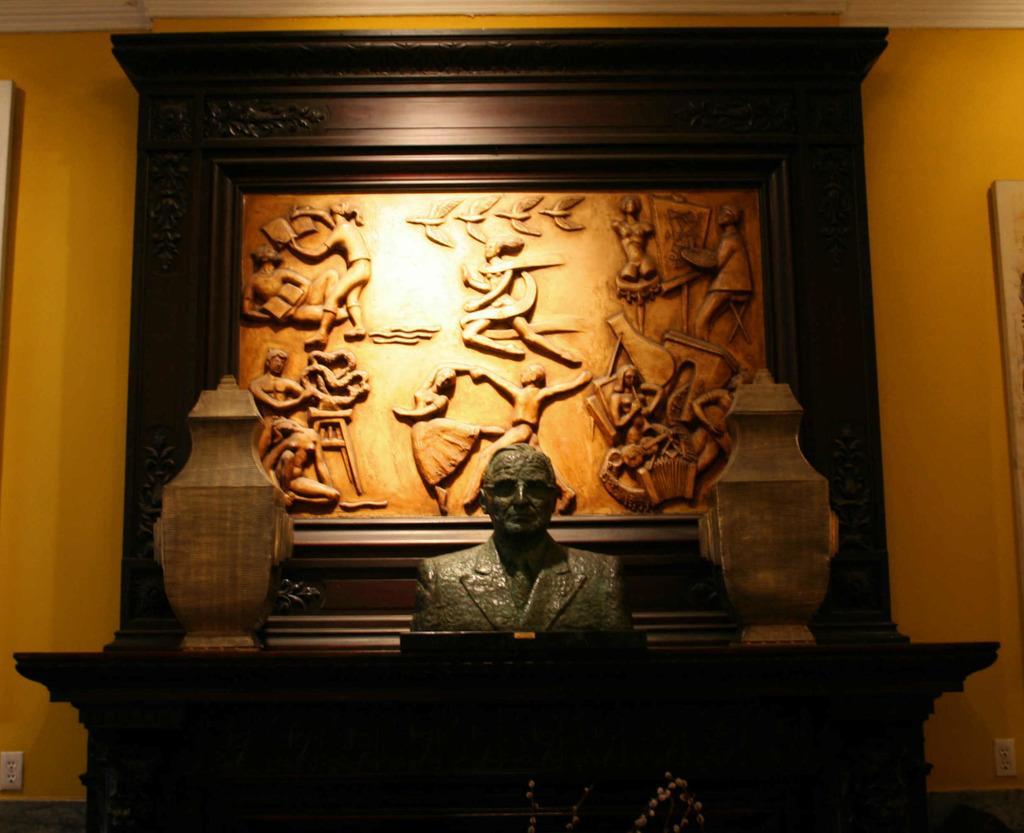Please provide a concise description of this image. In this picture there is a person statue on the table. Beside that we can see jar. On the back we can see statues of the persons. Here we can see a wooden frame which is on the wall. On the bottom left corner there is a socket. 